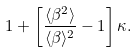<formula> <loc_0><loc_0><loc_500><loc_500>1 + \left [ { \frac { \langle \beta ^ { 2 } \rangle } { \langle \beta \rangle ^ { 2 } } - 1 } \right ] \kappa .</formula> 